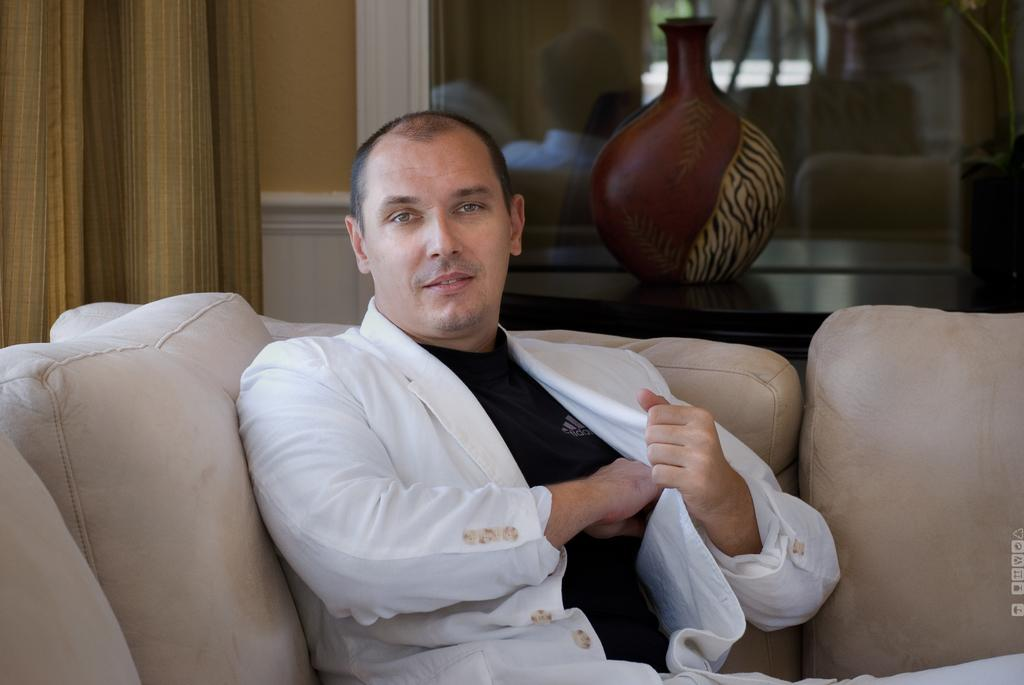What is the man in the image wearing? The man in the image is wearing a suit. What is the man doing in the image? The man is sitting on a couch. What can be seen in the background of the image? There is a curtain, a wall, and a glass element in the background of the image. What is the showpiece placed on in the image? The showpiece is placed on a black surface. How many babies are present in the image? There are no babies present in the image. What is the name of the place where the man is sitting in the image? The image does not provide information about the specific location or name of the place where the man is sitting. 